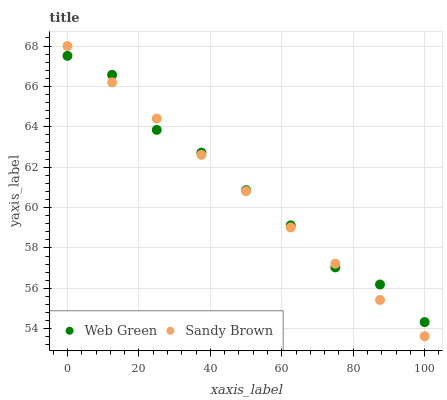Does Sandy Brown have the minimum area under the curve?
Answer yes or no. Yes. Does Web Green have the maximum area under the curve?
Answer yes or no. Yes. Does Web Green have the minimum area under the curve?
Answer yes or no. No. Is Sandy Brown the smoothest?
Answer yes or no. Yes. Is Web Green the roughest?
Answer yes or no. Yes. Is Web Green the smoothest?
Answer yes or no. No. Does Sandy Brown have the lowest value?
Answer yes or no. Yes. Does Web Green have the lowest value?
Answer yes or no. No. Does Sandy Brown have the highest value?
Answer yes or no. Yes. Does Web Green have the highest value?
Answer yes or no. No. Does Sandy Brown intersect Web Green?
Answer yes or no. Yes. Is Sandy Brown less than Web Green?
Answer yes or no. No. Is Sandy Brown greater than Web Green?
Answer yes or no. No. 